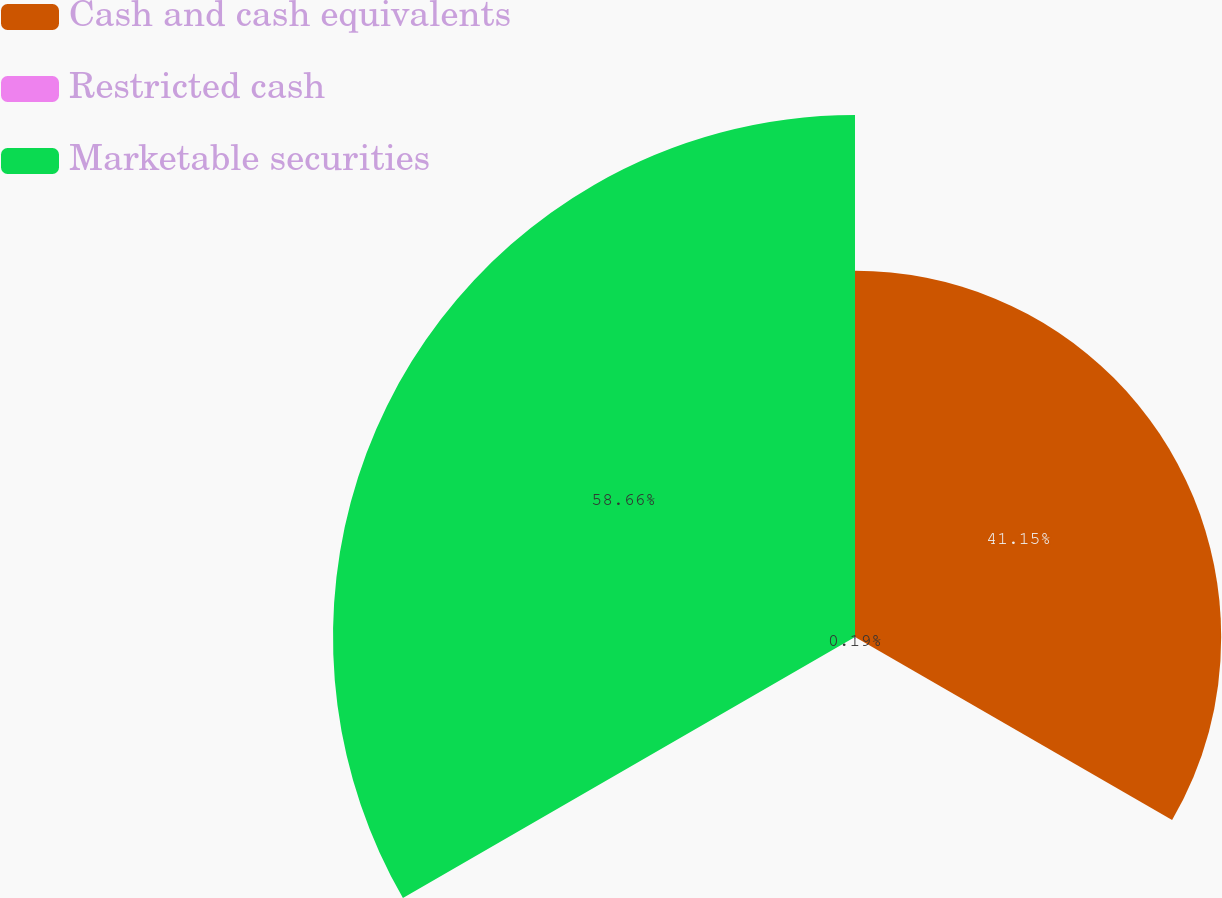<chart> <loc_0><loc_0><loc_500><loc_500><pie_chart><fcel>Cash and cash equivalents<fcel>Restricted cash<fcel>Marketable securities<nl><fcel>41.15%<fcel>0.19%<fcel>58.66%<nl></chart> 